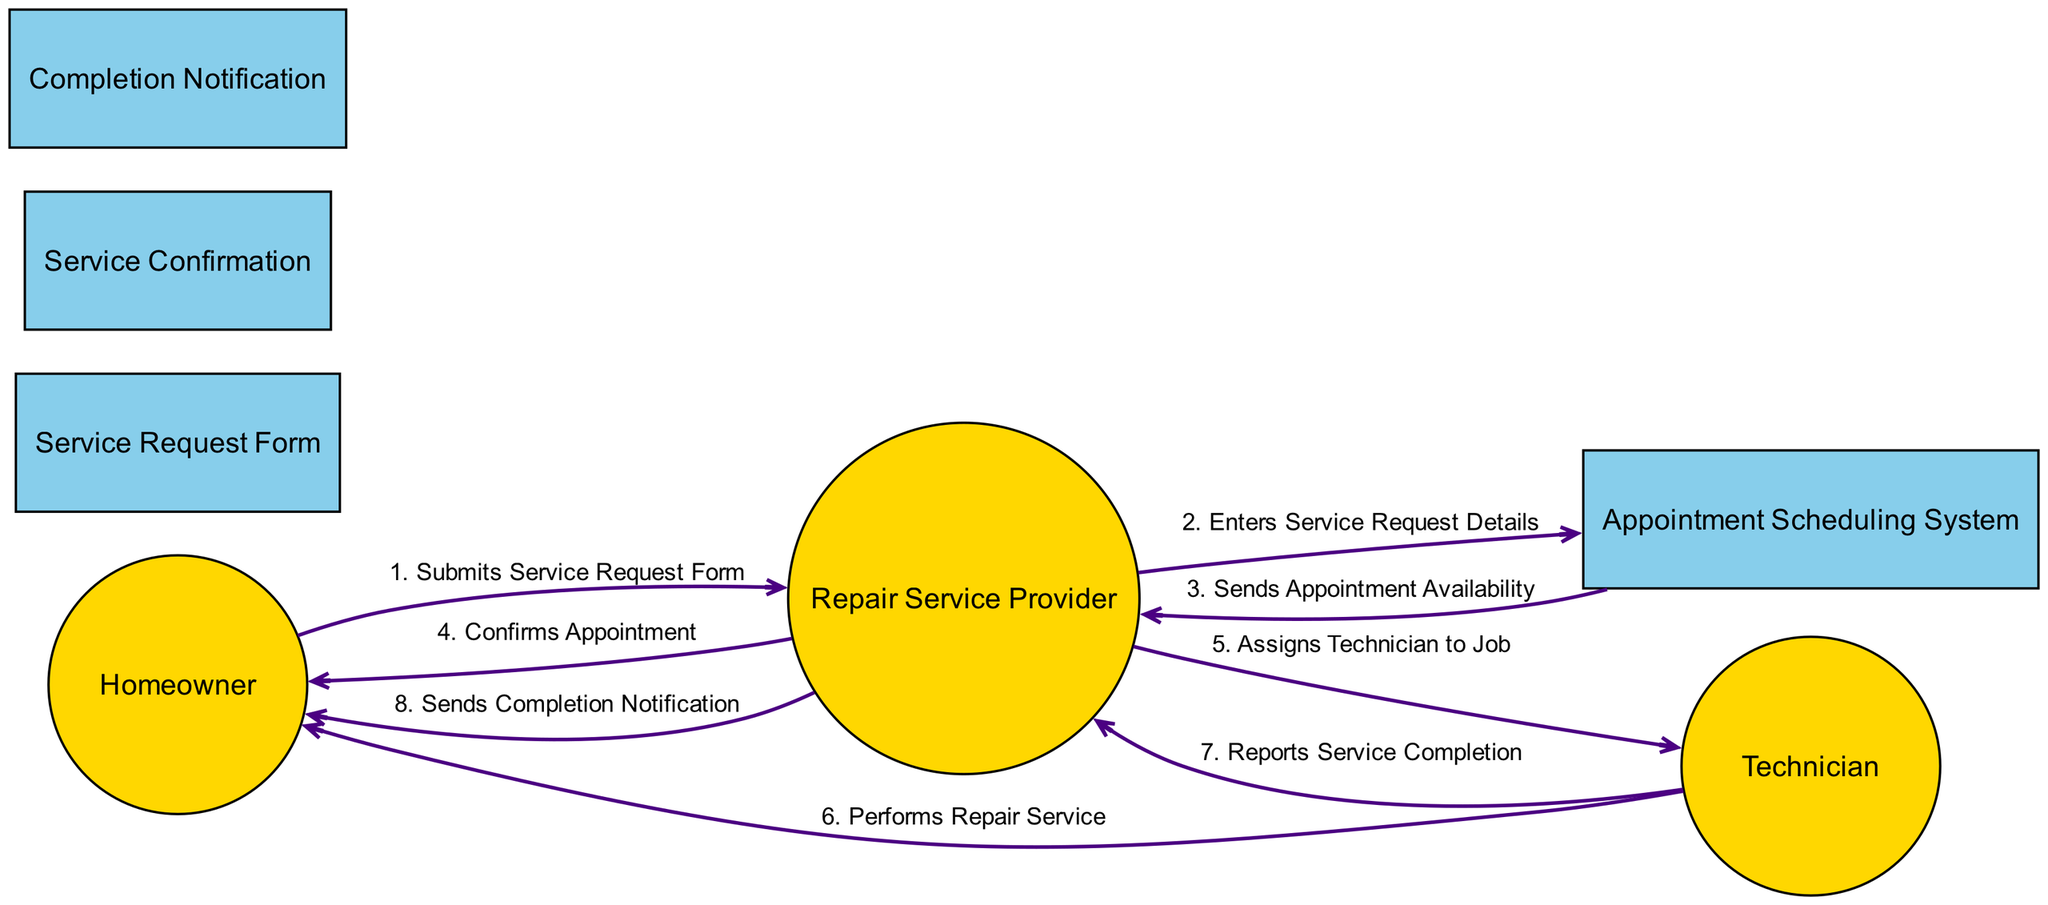What actor submits the service request form? The diagram shows that the "Homeowner" submits the "Service Request Form."
Answer: Homeowner How many objects are in the diagram? The diagram contains three objects: "Service Request Form," "Appointment Scheduling System," and "Completion Notification."
Answer: 3 What action follows the confirmation of the appointment? After "Repair Service Provider" confirms the appointment, the "Technician" performs the repair service.
Answer: Performs Repair Service Who receives the completion notification? The "Homeowner" is the recipient of the "Completion Notification" sent by the "Repair Service Provider."
Answer: Homeowner What is the third action in the sequence? The third action is when the "Appointment Scheduling System" sends appointment availability to the "Repair Service Provider."
Answer: Sends Appointment Availability How many edges are there connecting the actors? The diagram features four edges (connections) that involve the actors "Homeowner," "Repair Service Provider," and "Technician."
Answer: 4 Which component is responsible for assigning the technician to the job? The "Repair Service Provider" is responsible for assigning the "Technician" to the job.
Answer: Repair Service Provider What happens after the technician reports service completion? The action following the technician reporting service completion is that the "Repair Service Provider" sends a completion notification to the homeowner.
Answer: Sends Completion Notification What is the first action in the sequence? The first action in the sequence is when the "Homeowner" submits the "Service Request Form."
Answer: Submits Service Request Form 